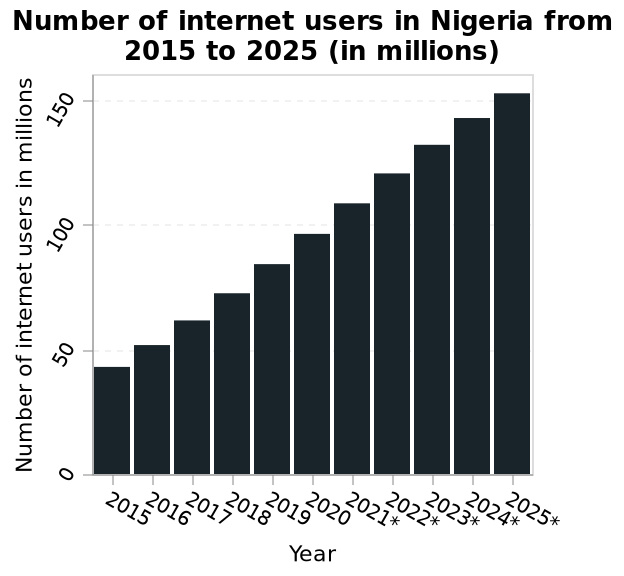<image>
What has been the trend in the number of Nigerian internet users from 2015 to 2022? The number of Nigerian internet users has steadily grown from 2015 to 2022. please describe the details of the chart This bar chart is labeled Number of internet users in Nigeria from 2015 to 2025 (in millions). On the x-axis, Year is defined. Number of internet users in millions is plotted on the y-axis. Is the growth in Nigerian internet users expected to continue beyond 2022? Yes, the growth in Nigerian internet users is predicted to continue until 2025. What is the range of years covered in the bar chart? The bar chart covers the period from 2015 to 2025. What is the forecast for the growth of Nigerian internet users until 2025? The forecast predicts that the growth of Nigerian internet users will continue until 2025. Does the forecast predict that the growth of Nigerian internet users will continue until 2020? No.The forecast predicts that the growth of Nigerian internet users will continue until 2025. 